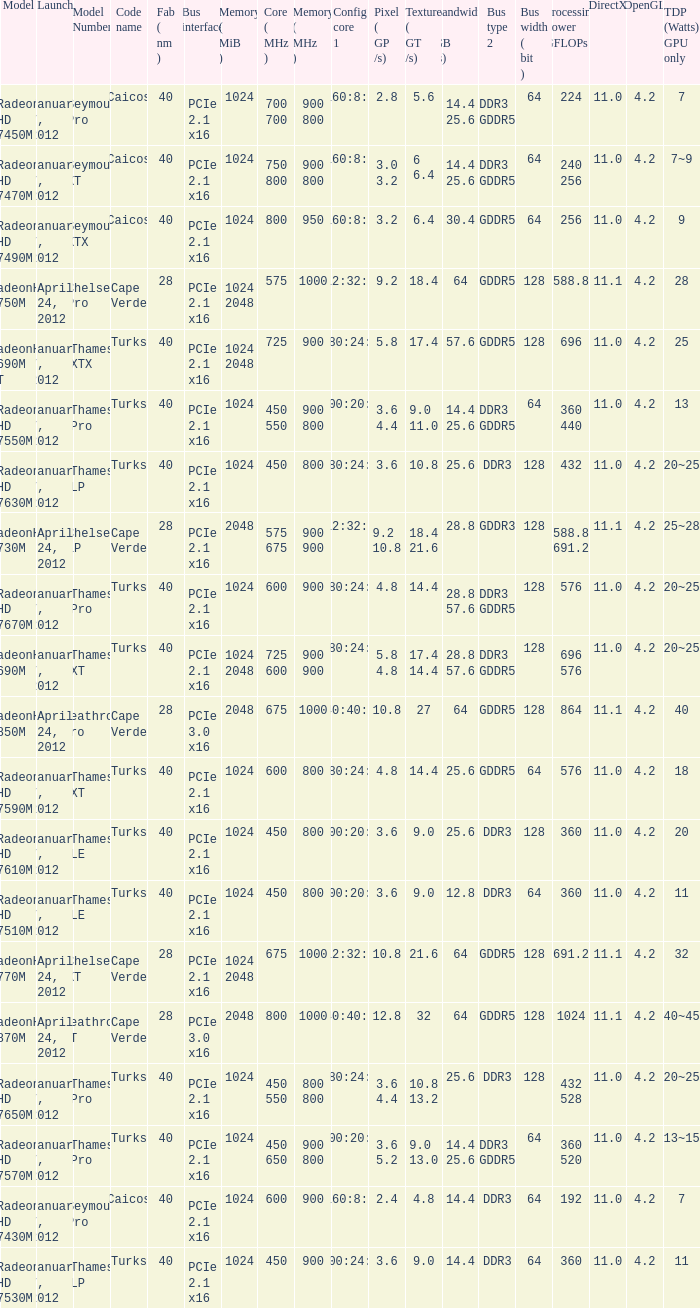Could you help me parse every detail presented in this table? {'header': ['Model', 'Launch', 'Model Number', 'Code name', 'Fab ( nm )', 'Bus interface', 'Memory ( MiB )', 'Core ( MHz )', 'Memory ( MHz )', 'Config core 1', 'Pixel ( GP /s)', 'Texture ( GT /s)', 'Bandwidth ( GB /s)', 'Bus type 2', 'Bus width ( bit )', 'Processing Power GFLOPs', 'DirectX', 'OpenGL', 'TDP (Watts) GPU only'], 'rows': [['Radeon HD 7450M', 'January 7, 2012', 'Seymour Pro', 'Caicos', '40', 'PCIe 2.1 x16', '1024', '700 700', '900 800', '160:8:4', '2.8', '5.6', '14.4 25.6', 'DDR3 GDDR5', '64', '224', '11.0', '4.2', '7'], ['Radeon HD 7470M', 'January 7, 2012', 'Seymour XT', 'Caicos', '40', 'PCIe 2.1 x16', '1024', '750 800', '900 800', '160:8:4', '3.0 3.2', '6 6.4', '14.4 25.6', 'DDR3 GDDR5', '64', '240 256', '11.0', '4.2', '7~9'], ['Radeon HD 7490M', 'January 7, 2012', 'Seymour XTX', 'Caicos', '40', 'PCIe 2.1 x16', '1024', '800', '950', '160:8:4', '3.2', '6.4', '30.4', 'GDDR5', '64', '256', '11.0', '4.2', '9'], ['RadeonHD 7750M', 'April 24, 2012', 'Chelsea Pro', 'Cape Verde', '28', 'PCIe 2.1 x16', '1024 2048', '575', '1000', '512:32:16', '9.2', '18.4', '64', 'GDDR5', '128', '588.8', '11.1', '4.2', '28'], ['RadeonHD 7690M XT', 'January 7, 2012', 'Thames XTX', 'Turks', '40', 'PCIe 2.1 x16', '1024 2048', '725', '900', '480:24:8', '5.8', '17.4', '57.6', 'GDDR5', '128', '696', '11.0', '4.2', '25'], ['Radeon HD 7550M', 'January 7, 2012', 'Thames Pro', 'Turks', '40', 'PCIe 2.1 x16', '1024', '450 550', '900 800', '400:20:8', '3.6 4.4', '9.0 11.0', '14.4 25.6', 'DDR3 GDDR5', '64', '360 440', '11.0', '4.2', '13'], ['Radeon HD 7630M', 'January 7, 2012', 'Thames LP', 'Turks', '40', 'PCIe 2.1 x16', '1024', '450', '800', '480:24:8', '3.6', '10.8', '25.6', 'DDR3', '128', '432', '11.0', '4.2', '20~25'], ['RadeonHD 7730M', 'April 24, 2012', 'Chelsea LP', 'Cape Verde', '28', 'PCIe 2.1 x16', '2048', '575 675', '900 900', '512:32:16', '9.2 10.8', '18.4 21.6', '28.8', 'GDDR3', '128', '588.8 691.2', '11.1', '4.2', '25~28'], ['Radeon HD 7670M', 'January 7, 2012', 'Thames Pro', 'Turks', '40', 'PCIe 2.1 x16', '1024', '600', '900', '480:24:8', '4.8', '14.4', '28.8 57.6', 'DDR3 GDDR5', '128', '576', '11.0', '4.2', '20~25'], ['RadeonHD 7690M', 'January 7, 2012', 'Thames XT', 'Turks', '40', 'PCIe 2.1 x16', '1024 2048', '725 600', '900 900', '480:24:8', '5.8 4.8', '17.4 14.4', '28.8 57.6', 'DDR3 GDDR5', '128', '696 576', '11.0', '4.2', '20~25'], ['RadeonHD 7850M', 'April 24, 2012', 'Heathrow Pro', 'Cape Verde', '28', 'PCIe 3.0 x16', '2048', '675', '1000', '640:40:16', '10.8', '27', '64', 'GDDR5', '128', '864', '11.1', '4.2', '40'], ['Radeon HD 7590M', 'January 7, 2012', 'Thames XT', 'Turks', '40', 'PCIe 2.1 x16', '1024', '600', '800', '480:24:8', '4.8', '14.4', '25.6', 'GDDR5', '64', '576', '11.0', '4.2', '18'], ['Radeon HD 7610M', 'January 7, 2012', 'Thames LE', 'Turks', '40', 'PCIe 2.1 x16', '1024', '450', '800', '400:20:8', '3.6', '9.0', '25.6', 'DDR3', '128', '360', '11.0', '4.2', '20'], ['Radeon HD 7510M', 'January 7, 2012', 'Thames LE', 'Turks', '40', 'PCIe 2.1 x16', '1024', '450', '800', '400:20:8', '3.6', '9.0', '12.8', 'DDR3', '64', '360', '11.0', '4.2', '11'], ['RadeonHD 7770M', 'April 24, 2012', 'Chelsea XT', 'Cape Verde', '28', 'PCIe 2.1 x16', '1024 2048', '675', '1000', '512:32:16', '10.8', '21.6', '64', 'GDDR5', '128', '691.2', '11.1', '4.2', '32'], ['RadeonHD 7870M', 'April 24, 2012', 'Heathrow XT', 'Cape Verde', '28', 'PCIe 3.0 x16', '2048', '800', '1000', '640:40:16', '12.8', '32', '64', 'GDDR5', '128', '1024', '11.1', '4.2', '40~45'], ['Radeon HD 7650M', 'January 7, 2012', 'Thames Pro', 'Turks', '40', 'PCIe 2.1 x16', '1024', '450 550', '800 800', '480:24:8', '3.6 4.4', '10.8 13.2', '25.6', 'DDR3', '128', '432 528', '11.0', '4.2', '20~25'], ['Radeon HD 7570M', 'January 7, 2012', 'Thames Pro', 'Turks', '40', 'PCIe 2.1 x16', '1024', '450 650', '900 800', '400:20:8', '3.6 5.2', '9.0 13.0', '14.4 25.6', 'DDR3 GDDR5', '64', '360 520', '11.0', '4.2', '13~15'], ['Radeon HD 7430M', 'January 7, 2012', 'Seymour Pro', 'Caicos', '40', 'PCIe 2.1 x16', '1024', '600', '900', '160:8:4', '2.4', '4.8', '14.4', 'DDR3', '64', '192', '11.0', '4.2', '7'], ['Radeon HD 7530M', 'January 7, 2012', 'Thames LP', 'Turks', '40', 'PCIe 2.1 x16', '1024', '450', '900', '400:24:8', '3.6', '9.0', '14.4', 'DDR3', '64', '360', '11.0', '4.2', '11']]} How many texture (gt/s) the card has if the tdp (watts) GPU only is 18? 1.0. 